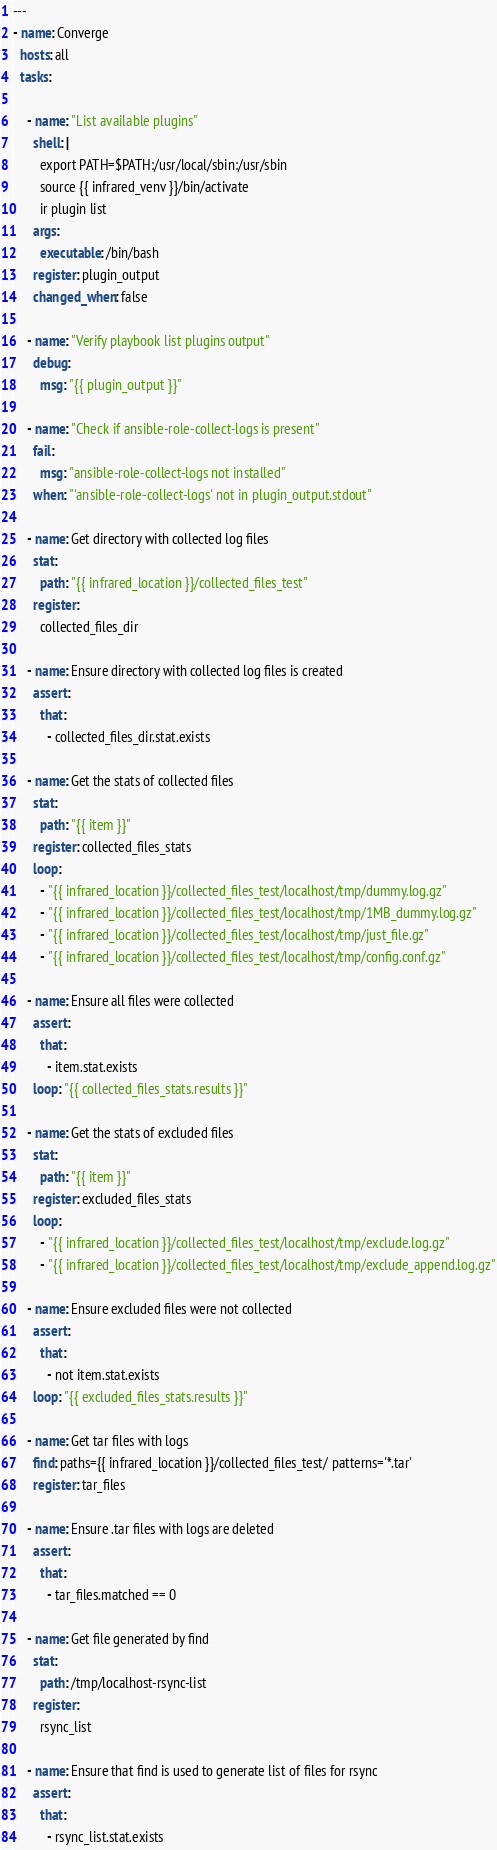<code> <loc_0><loc_0><loc_500><loc_500><_YAML_>---
- name: Converge
  hosts: all
  tasks:

    - name: "List available plugins"
      shell: |
        export PATH=$PATH:/usr/local/sbin:/usr/sbin
        source {{ infrared_venv }}/bin/activate
        ir plugin list
      args:
        executable: /bin/bash
      register: plugin_output
      changed_when: false

    - name: "Verify playbook list plugins output"
      debug:
        msg: "{{ plugin_output }}"

    - name: "Check if ansible-role-collect-logs is present"
      fail:
        msg: "ansible-role-collect-logs not installed"
      when: "'ansible-role-collect-logs' not in plugin_output.stdout"

    - name: Get directory with collected log files
      stat:
        path: "{{ infrared_location }}/collected_files_test"
      register:
        collected_files_dir

    - name: Ensure directory with collected log files is created
      assert:
        that:
          - collected_files_dir.stat.exists

    - name: Get the stats of collected files
      stat:
        path: "{{ item }}"
      register: collected_files_stats
      loop:
        - "{{ infrared_location }}/collected_files_test/localhost/tmp/dummy.log.gz"
        - "{{ infrared_location }}/collected_files_test/localhost/tmp/1MB_dummy.log.gz"
        - "{{ infrared_location }}/collected_files_test/localhost/tmp/just_file.gz"
        - "{{ infrared_location }}/collected_files_test/localhost/tmp/config.conf.gz"

    - name: Ensure all files were collected
      assert:
        that:
          - item.stat.exists
      loop: "{{ collected_files_stats.results }}"

    - name: Get the stats of excluded files
      stat:
        path: "{{ item }}"
      register: excluded_files_stats
      loop:
        - "{{ infrared_location }}/collected_files_test/localhost/tmp/exclude.log.gz"
        - "{{ infrared_location }}/collected_files_test/localhost/tmp/exclude_append.log.gz"

    - name: Ensure excluded files were not collected
      assert:
        that:
          - not item.stat.exists
      loop: "{{ excluded_files_stats.results }}"

    - name: Get tar files with logs
      find: paths={{ infrared_location }}/collected_files_test/ patterns='*.tar'
      register: tar_files

    - name: Ensure .tar files with logs are deleted
      assert:
        that:
          - tar_files.matched == 0

    - name: Get file generated by find
      stat:
        path: /tmp/localhost-rsync-list
      register:
        rsync_list

    - name: Ensure that find is used to generate list of files for rsync
      assert:
        that:
          - rsync_list.stat.exists
</code> 